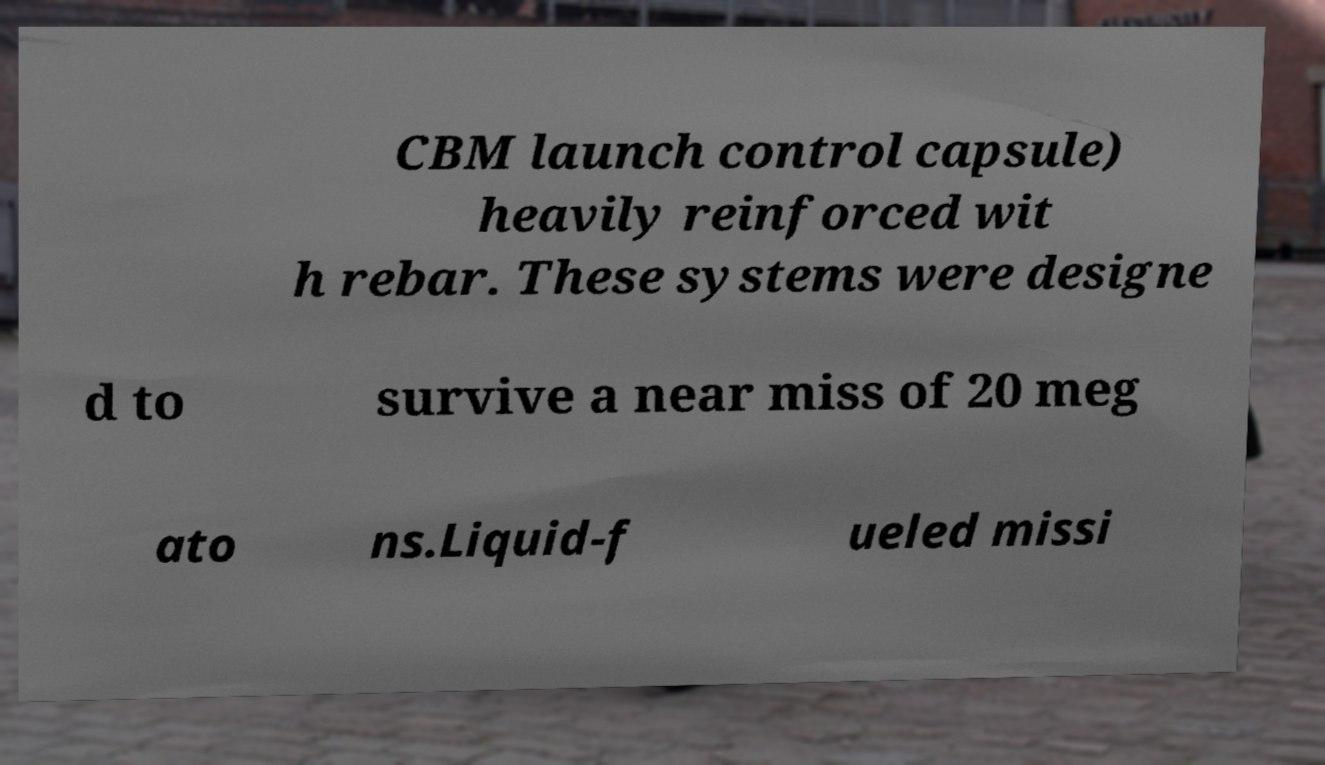There's text embedded in this image that I need extracted. Can you transcribe it verbatim? CBM launch control capsule) heavily reinforced wit h rebar. These systems were designe d to survive a near miss of 20 meg ato ns.Liquid-f ueled missi 